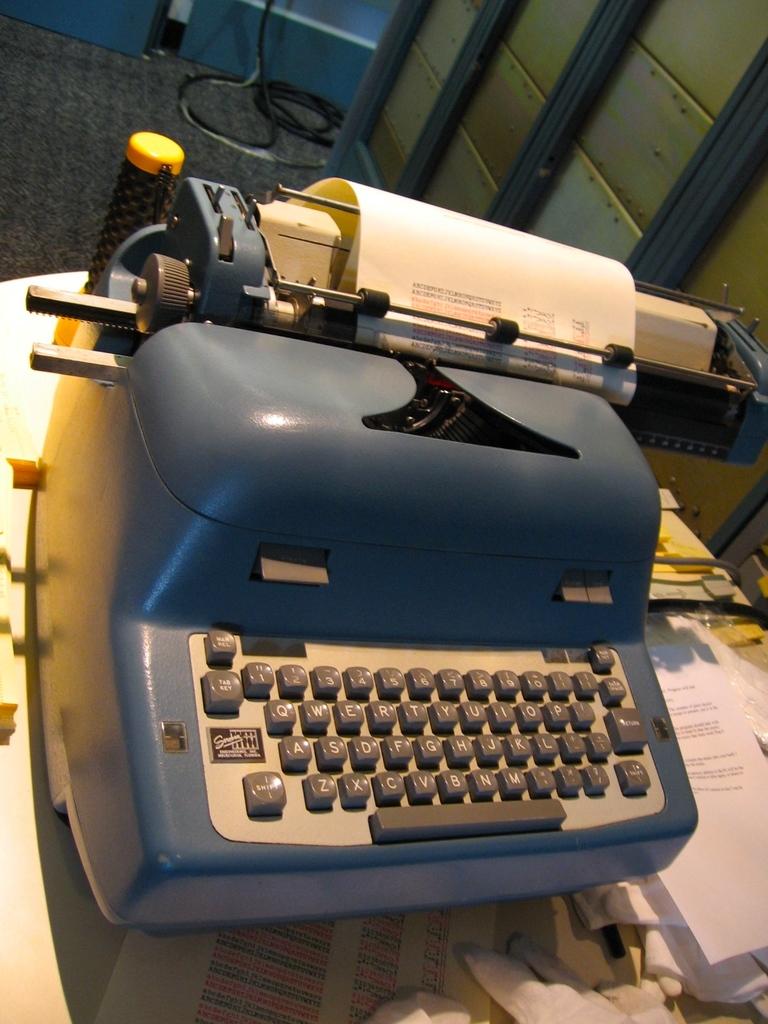Is this a qwerty keyboard?
Your answer should be very brief. Yes. What letters are on the bottom row of the keyboard?
Offer a very short reply. Zxcvbnm. 